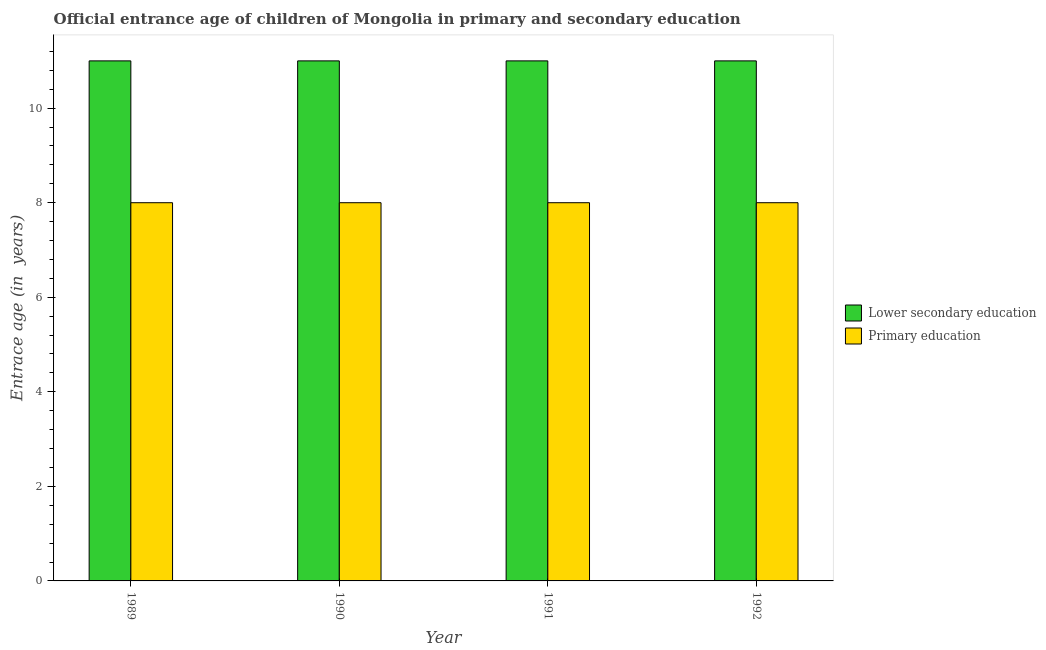How many different coloured bars are there?
Offer a very short reply. 2. How many groups of bars are there?
Your answer should be very brief. 4. How many bars are there on the 2nd tick from the left?
Provide a short and direct response. 2. How many bars are there on the 4th tick from the right?
Make the answer very short. 2. What is the label of the 3rd group of bars from the left?
Ensure brevity in your answer.  1991. What is the entrance age of children in lower secondary education in 1991?
Your answer should be very brief. 11. Across all years, what is the maximum entrance age of chiildren in primary education?
Your answer should be compact. 8. Across all years, what is the minimum entrance age of children in lower secondary education?
Your response must be concise. 11. In which year was the entrance age of chiildren in primary education maximum?
Give a very brief answer. 1989. In which year was the entrance age of chiildren in primary education minimum?
Your response must be concise. 1989. What is the total entrance age of children in lower secondary education in the graph?
Keep it short and to the point. 44. In how many years, is the entrance age of chiildren in primary education greater than 6.4 years?
Ensure brevity in your answer.  4. What is the ratio of the entrance age of children in lower secondary education in 1991 to that in 1992?
Your response must be concise. 1. What does the 2nd bar from the left in 1990 represents?
Your response must be concise. Primary education. What does the 2nd bar from the right in 1989 represents?
Offer a very short reply. Lower secondary education. Are all the bars in the graph horizontal?
Provide a succinct answer. No. How many years are there in the graph?
Make the answer very short. 4. What is the difference between two consecutive major ticks on the Y-axis?
Your response must be concise. 2. Are the values on the major ticks of Y-axis written in scientific E-notation?
Your answer should be very brief. No. Does the graph contain grids?
Your answer should be very brief. No. What is the title of the graph?
Give a very brief answer. Official entrance age of children of Mongolia in primary and secondary education. Does "Highest 10% of population" appear as one of the legend labels in the graph?
Give a very brief answer. No. What is the label or title of the Y-axis?
Your response must be concise. Entrace age (in  years). What is the Entrace age (in  years) in Primary education in 1989?
Provide a short and direct response. 8. What is the Entrace age (in  years) of Primary education in 1990?
Provide a succinct answer. 8. What is the Entrace age (in  years) of Primary education in 1991?
Your answer should be very brief. 8. What is the Entrace age (in  years) in Lower secondary education in 1992?
Offer a terse response. 11. What is the Entrace age (in  years) in Primary education in 1992?
Your response must be concise. 8. Across all years, what is the maximum Entrace age (in  years) in Lower secondary education?
Make the answer very short. 11. Across all years, what is the maximum Entrace age (in  years) of Primary education?
Offer a terse response. 8. Across all years, what is the minimum Entrace age (in  years) of Lower secondary education?
Ensure brevity in your answer.  11. What is the total Entrace age (in  years) of Lower secondary education in the graph?
Provide a short and direct response. 44. What is the difference between the Entrace age (in  years) of Lower secondary education in 1989 and that in 1990?
Your answer should be compact. 0. What is the difference between the Entrace age (in  years) in Primary education in 1989 and that in 1990?
Offer a very short reply. 0. What is the difference between the Entrace age (in  years) in Lower secondary education in 1989 and that in 1991?
Your response must be concise. 0. What is the difference between the Entrace age (in  years) of Lower secondary education in 1989 and that in 1992?
Offer a very short reply. 0. What is the difference between the Entrace age (in  years) in Lower secondary education in 1990 and that in 1992?
Give a very brief answer. 0. What is the difference between the Entrace age (in  years) of Primary education in 1990 and that in 1992?
Keep it short and to the point. 0. What is the difference between the Entrace age (in  years) in Primary education in 1991 and that in 1992?
Make the answer very short. 0. What is the difference between the Entrace age (in  years) of Lower secondary education in 1989 and the Entrace age (in  years) of Primary education in 1992?
Offer a very short reply. 3. What is the average Entrace age (in  years) of Lower secondary education per year?
Provide a short and direct response. 11. In the year 1989, what is the difference between the Entrace age (in  years) of Lower secondary education and Entrace age (in  years) of Primary education?
Your answer should be compact. 3. In the year 1990, what is the difference between the Entrace age (in  years) in Lower secondary education and Entrace age (in  years) in Primary education?
Your answer should be very brief. 3. In the year 1992, what is the difference between the Entrace age (in  years) of Lower secondary education and Entrace age (in  years) of Primary education?
Provide a short and direct response. 3. What is the ratio of the Entrace age (in  years) in Primary education in 1989 to that in 1991?
Ensure brevity in your answer.  1. What is the ratio of the Entrace age (in  years) of Primary education in 1989 to that in 1992?
Your answer should be compact. 1. What is the ratio of the Entrace age (in  years) in Primary education in 1990 to that in 1991?
Your answer should be compact. 1. What is the difference between the highest and the second highest Entrace age (in  years) in Primary education?
Your response must be concise. 0. What is the difference between the highest and the lowest Entrace age (in  years) of Primary education?
Provide a short and direct response. 0. 